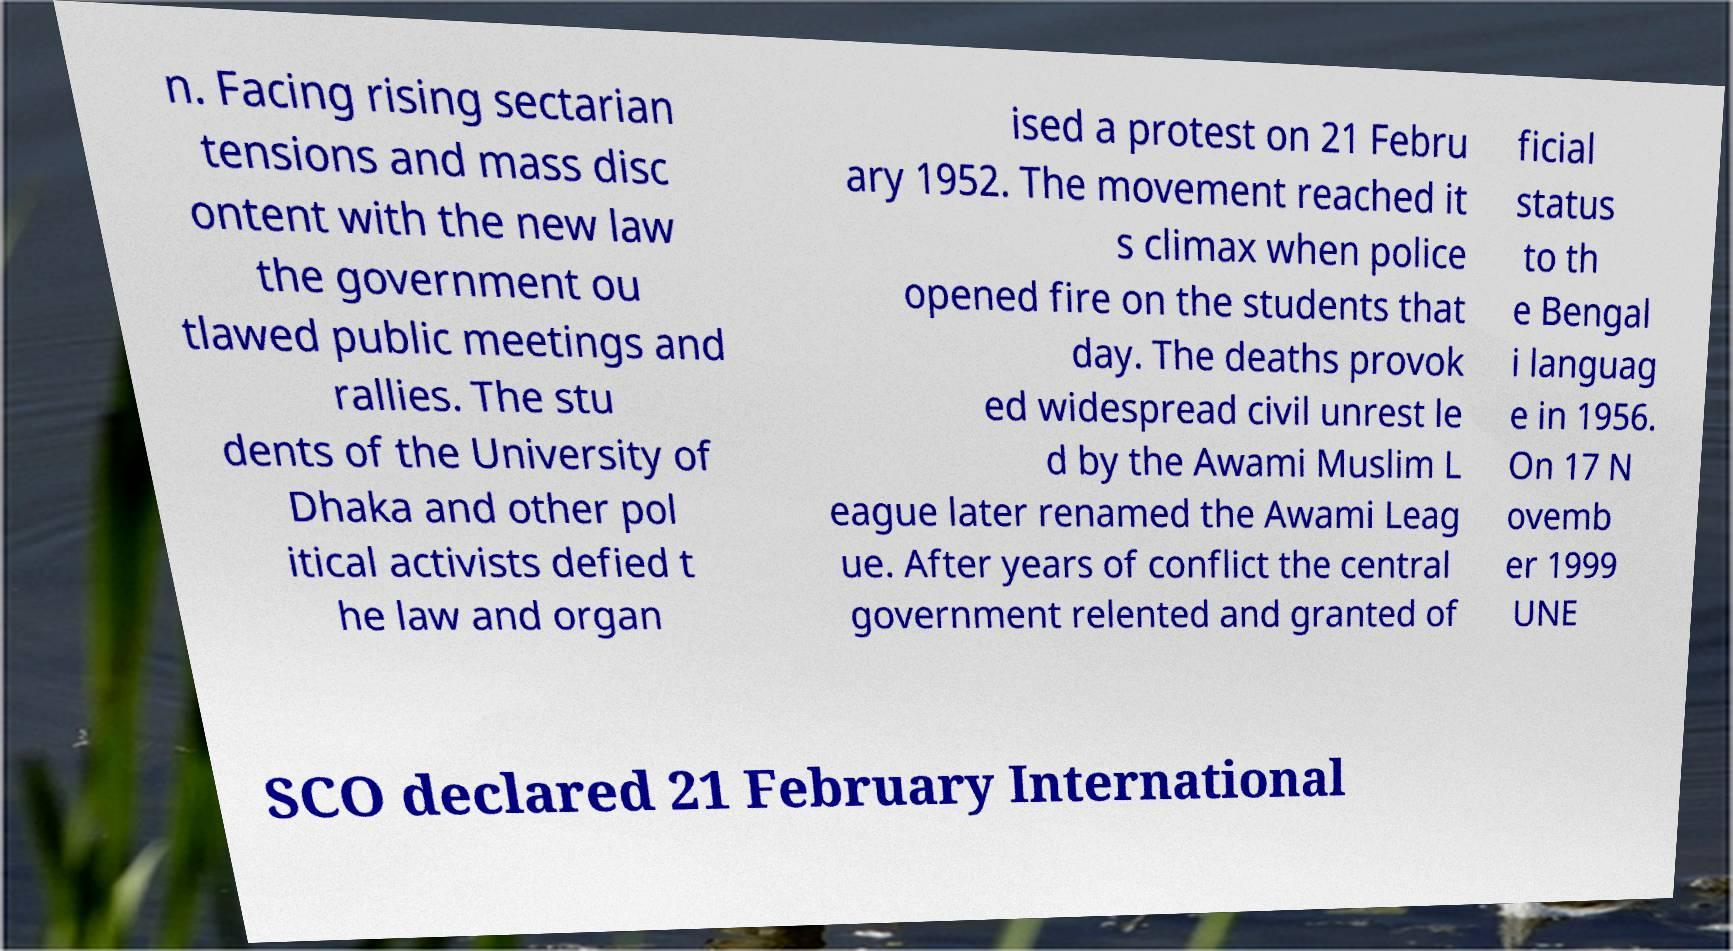Could you assist in decoding the text presented in this image and type it out clearly? n. Facing rising sectarian tensions and mass disc ontent with the new law the government ou tlawed public meetings and rallies. The stu dents of the University of Dhaka and other pol itical activists defied t he law and organ ised a protest on 21 Febru ary 1952. The movement reached it s climax when police opened fire on the students that day. The deaths provok ed widespread civil unrest le d by the Awami Muslim L eague later renamed the Awami Leag ue. After years of conflict the central government relented and granted of ficial status to th e Bengal i languag e in 1956. On 17 N ovemb er 1999 UNE SCO declared 21 February International 